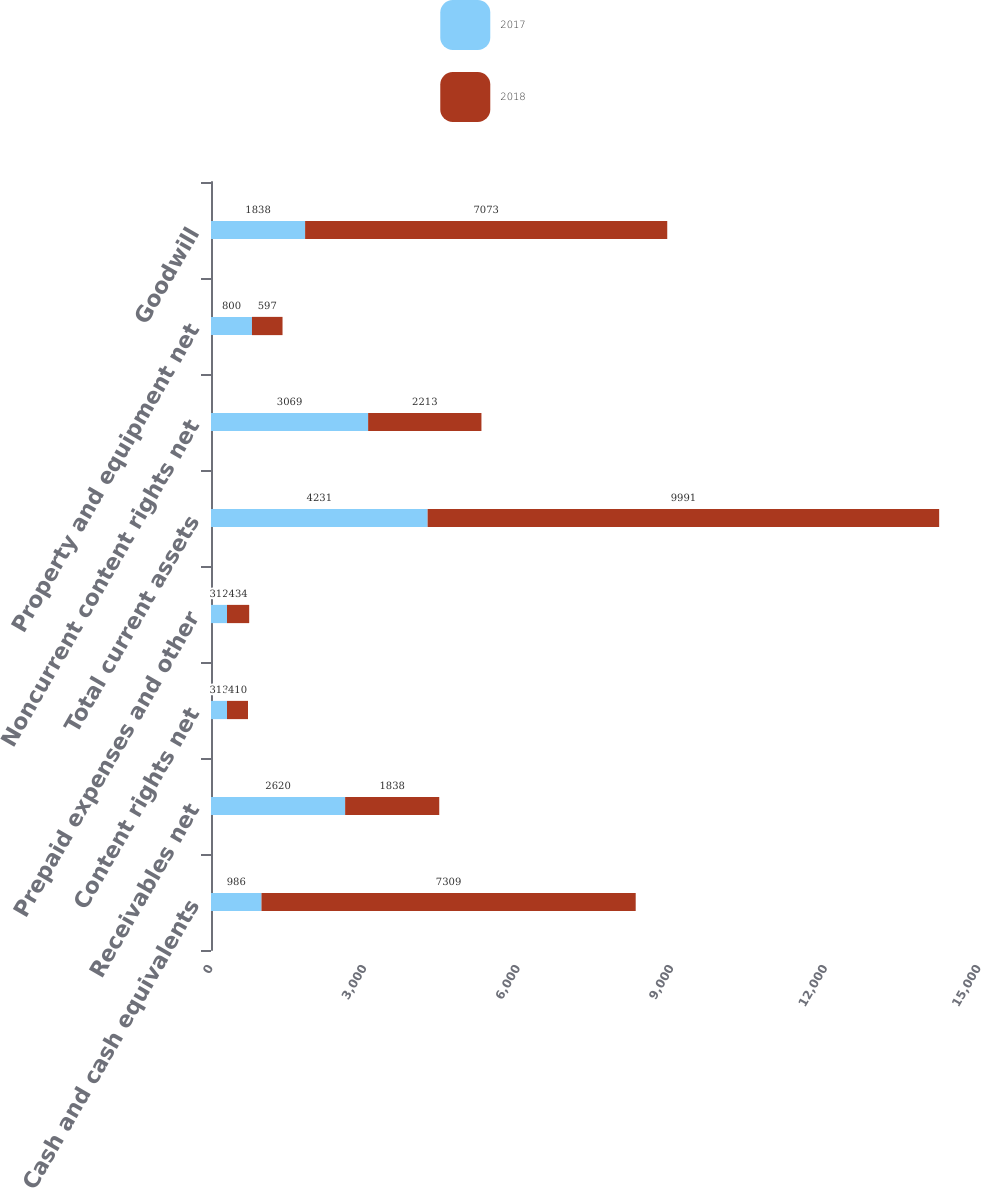Convert chart to OTSL. <chart><loc_0><loc_0><loc_500><loc_500><stacked_bar_chart><ecel><fcel>Cash and cash equivalents<fcel>Receivables net<fcel>Content rights net<fcel>Prepaid expenses and other<fcel>Total current assets<fcel>Noncurrent content rights net<fcel>Property and equipment net<fcel>Goodwill<nl><fcel>2017<fcel>986<fcel>2620<fcel>313<fcel>312<fcel>4231<fcel>3069<fcel>800<fcel>1838<nl><fcel>2018<fcel>7309<fcel>1838<fcel>410<fcel>434<fcel>9991<fcel>2213<fcel>597<fcel>7073<nl></chart> 